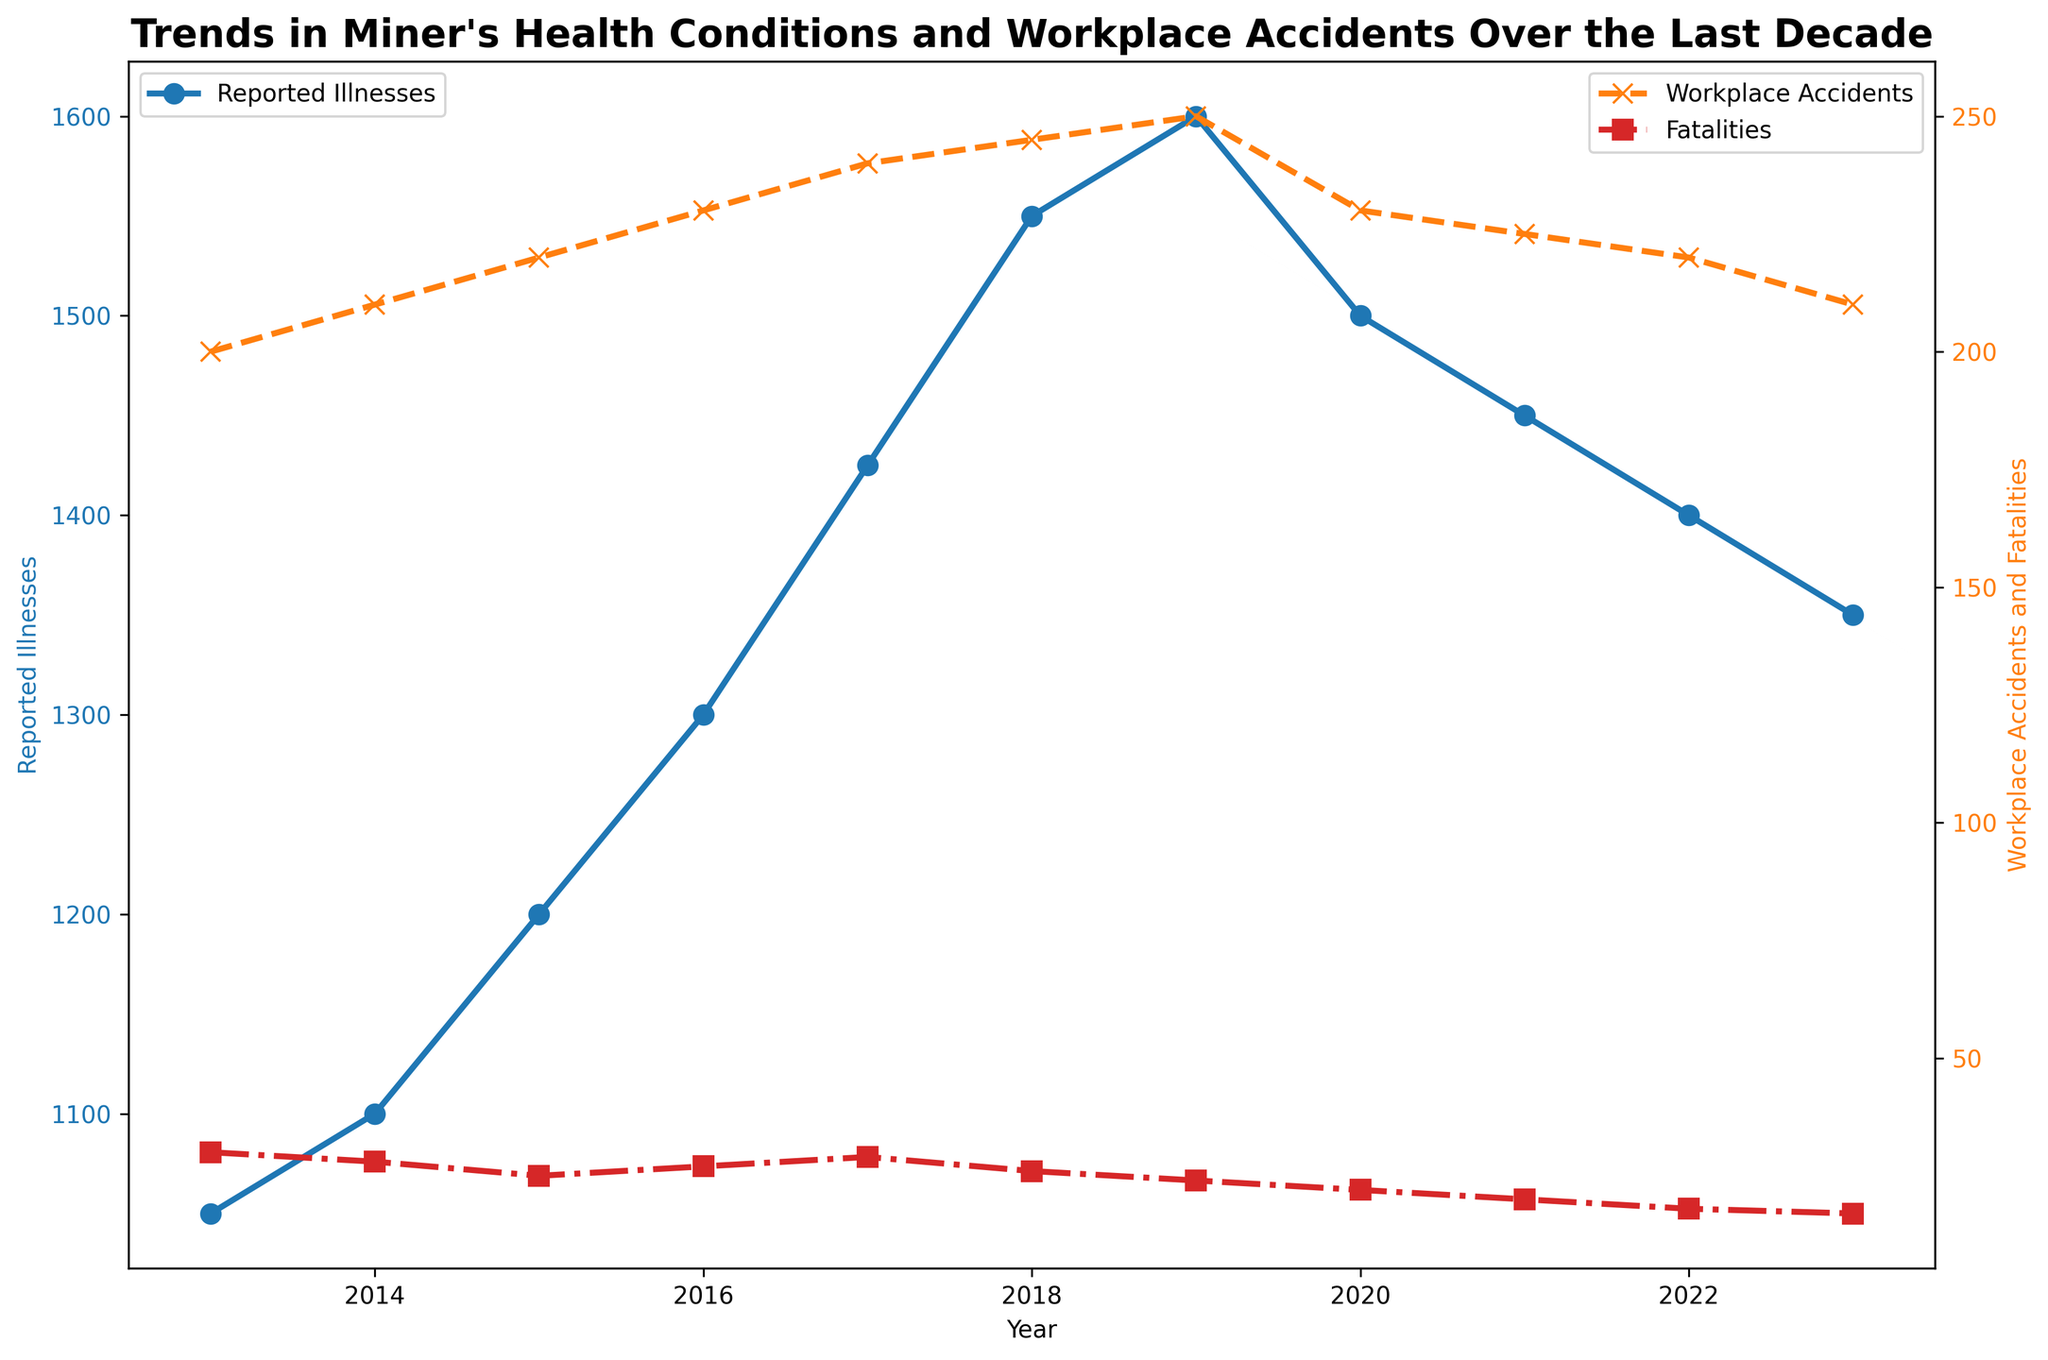Which year had the highest number of reported illnesses? Look at the blue line representing reported illnesses and identify the peak point. The highest value occurs in 2019 at 1600 cases.
Answer: 2019 When were workplace accidents the lowest? Look at the orange dashed line representing workplace accidents and identify the lowest point. The lowest value occurs in 2013 at 200 incidents.
Answer: 2013 How much did the number of reported illnesses increase from 2013 to 2015? Subtract the number of reported illnesses in 2013 (1050) from the number in 2015 (1200): 1200 - 1050 = 150.
Answer: 150 Compare the number of workplace accidents and reported illnesses in 2018. Which was higher, and by how much? The number of workplace accidents in 2018 was 245, and the number of reported illnesses was 1550. The difference is 1550 - 245 = 1305.
Answer: Reported illnesses by 1305 In which year did fatalities drop below 20 for the first time? Look at the red dotted line representing fatalities and find the year when the value first drops below 20. This happens in 2022, with a value of 18.
Answer: 2022 Calculate the average number of fatalities over the decade. Sum all fatality values (30 + 28 + 25 + 27 + 29 + 26 + 24 + 22 + 20 + 18 + 17 = 266) and divide by the number of years (11): 266 / 11 ≈ 24.18.
Answer: 24.18 How many years saw an increase in reported illnesses compared to the previous year? Track the blue line for reported illnesses year by year and count the increases: 2014, 2015, 2016, 2017, 2018, 2019. This results in 6 years of increase.
Answer: 6 Which two years had the closest values of workplace accidents? Identify years with similar orange dashed line values. 2018 and 2019 have very close values, 245 and 250, respectively. The difference is just 5.
Answer: 2018 and 2019 In what year did the trend in reported illnesses reverse and start to decrease? Look at the blue line representing reported illnesses, which peaks in 2019 and decreases in 2020. Thus, 2019 is when the trend reversed.
Answer: 2019 By how much did the number of fatalities decrease from 2013 to 2023? Subtract the number of fatalities in 2023 (17) from the number in 2013 (30): 30 - 17 = 13.
Answer: 13 